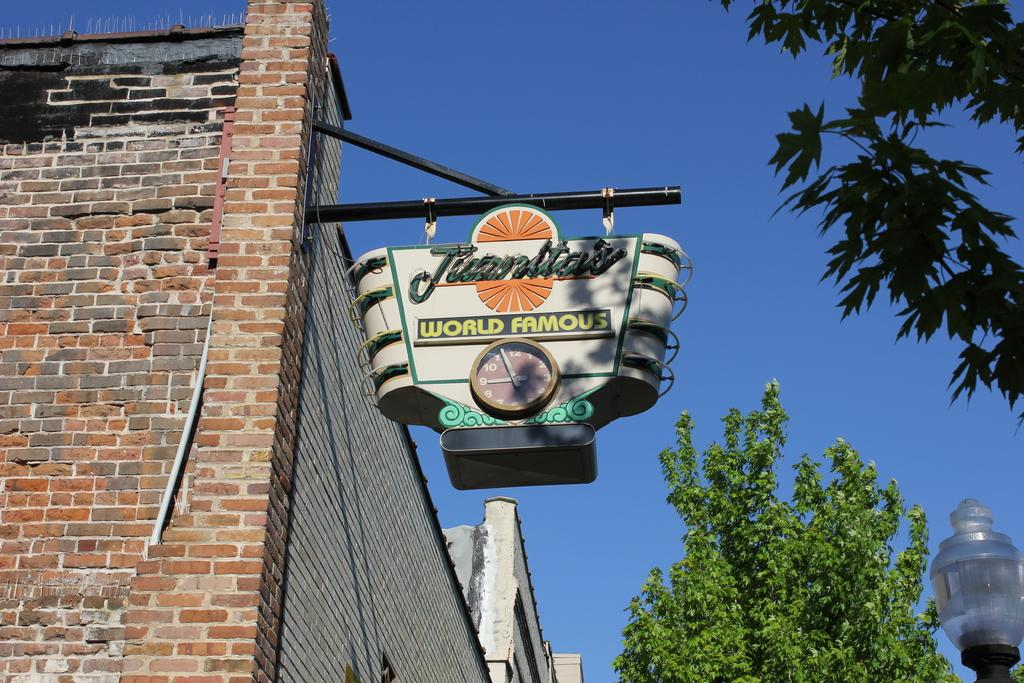What is the main object in the image? There is a name board with a clock in the image. What type of structure can be seen in the image? There is a building in the image. What natural elements are present in the image? There are trees in the image. Can you describe the lighting in the image? There is light visible in the image. What can be seen in the background of the image? The sky is visible in the background of the image. What type of feather can be seen on the name board in the image? There is no feather present on the name board in the image. Can you tell me the name of the father in the image? There is no person or father mentioned or depicted in the image. 